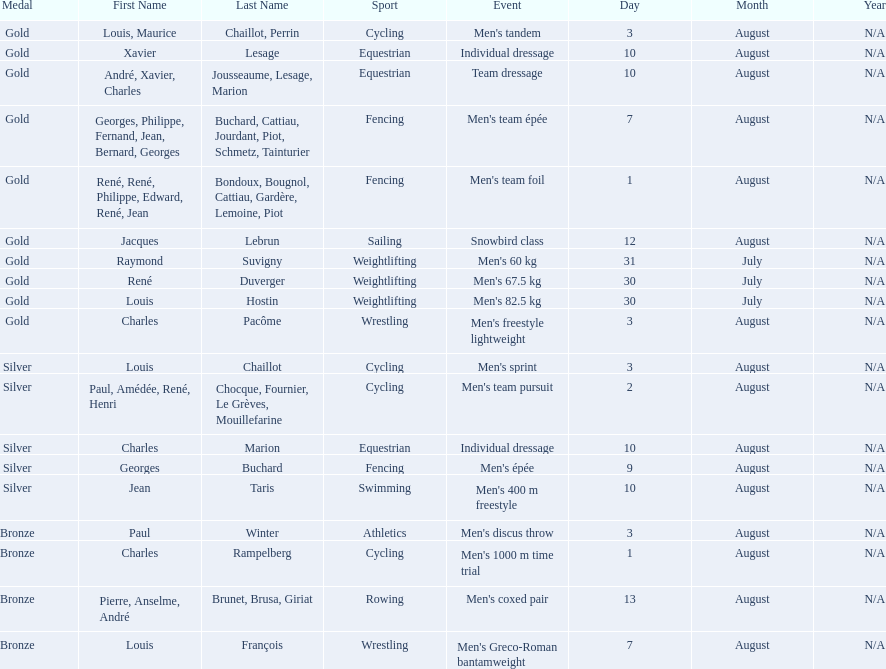Which event won the most medals? Cycling. 